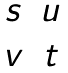<formula> <loc_0><loc_0><loc_500><loc_500>\begin{matrix} s & u \\ v & t \end{matrix}</formula> 